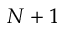<formula> <loc_0><loc_0><loc_500><loc_500>N + 1</formula> 